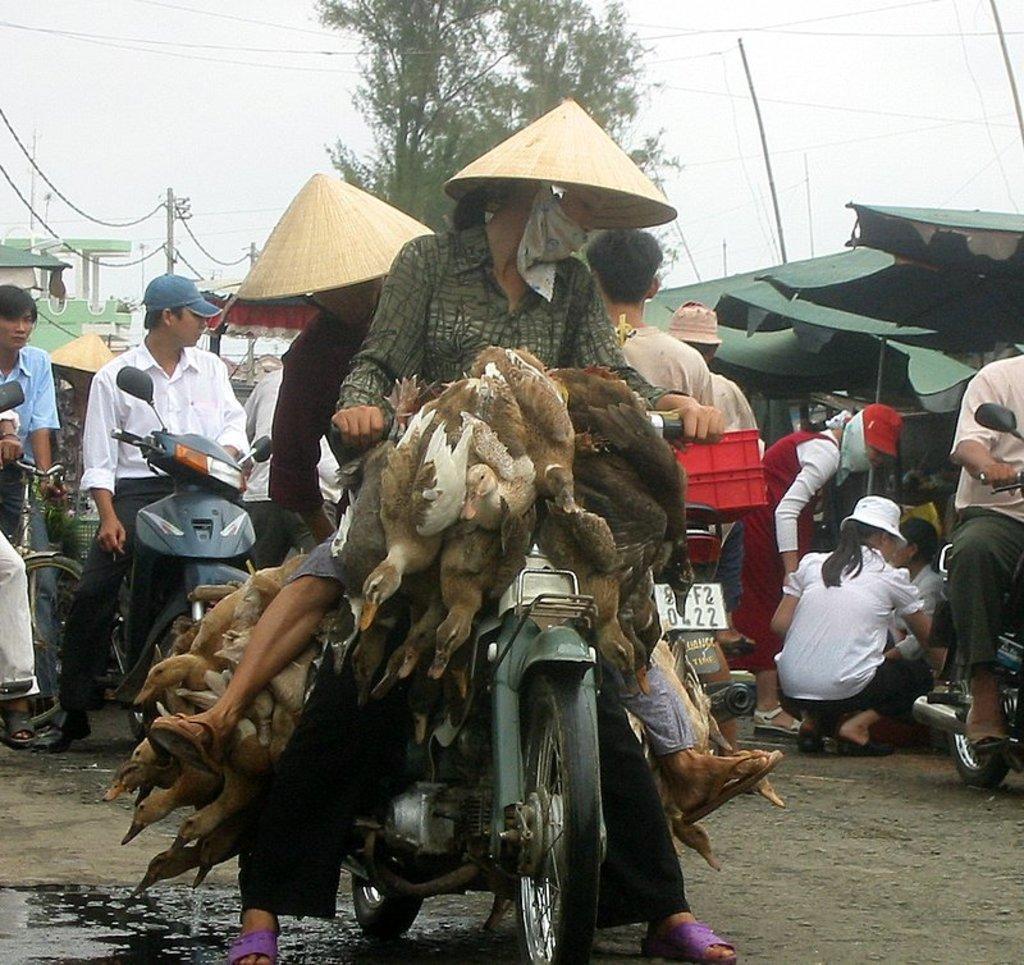Can you describe this image briefly? In this image we can see two people wearing the hats sitting on a motorbike. We can also see a group of hens tied to the motor mike. On the backside we can see a group of people. In that some are sitting on the vehicles. We can also see the roof, some poles with wires, a building, a tree and the sky which looks cloudy. 